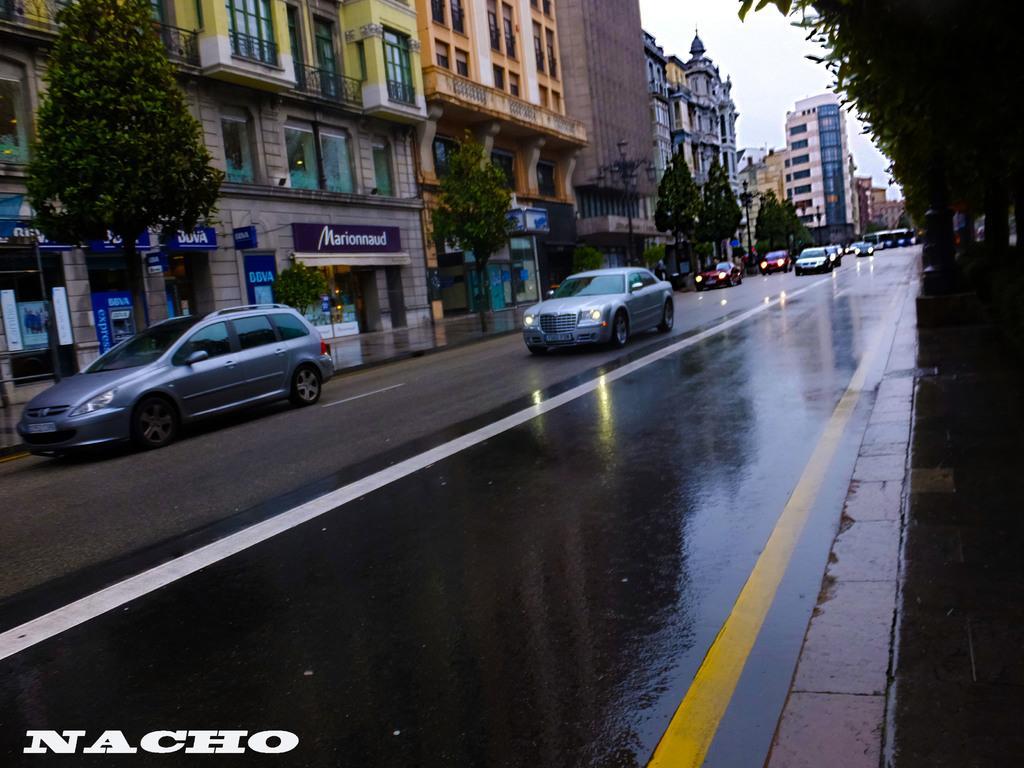Describe this image in one or two sentences. In this image there are cars on a road, on either side of the road there are trees, in the background there are buildings, in the bottom left there is text. 